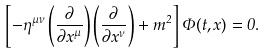<formula> <loc_0><loc_0><loc_500><loc_500>\left [ - \eta ^ { \mu \nu } \left ( \frac { \partial } { \partial x ^ { \mu } } \right ) \left ( \frac { \partial } { \partial x ^ { \nu } } \right ) + m ^ { 2 } \right ] \Phi ( t , { x } ) = 0 .</formula> 